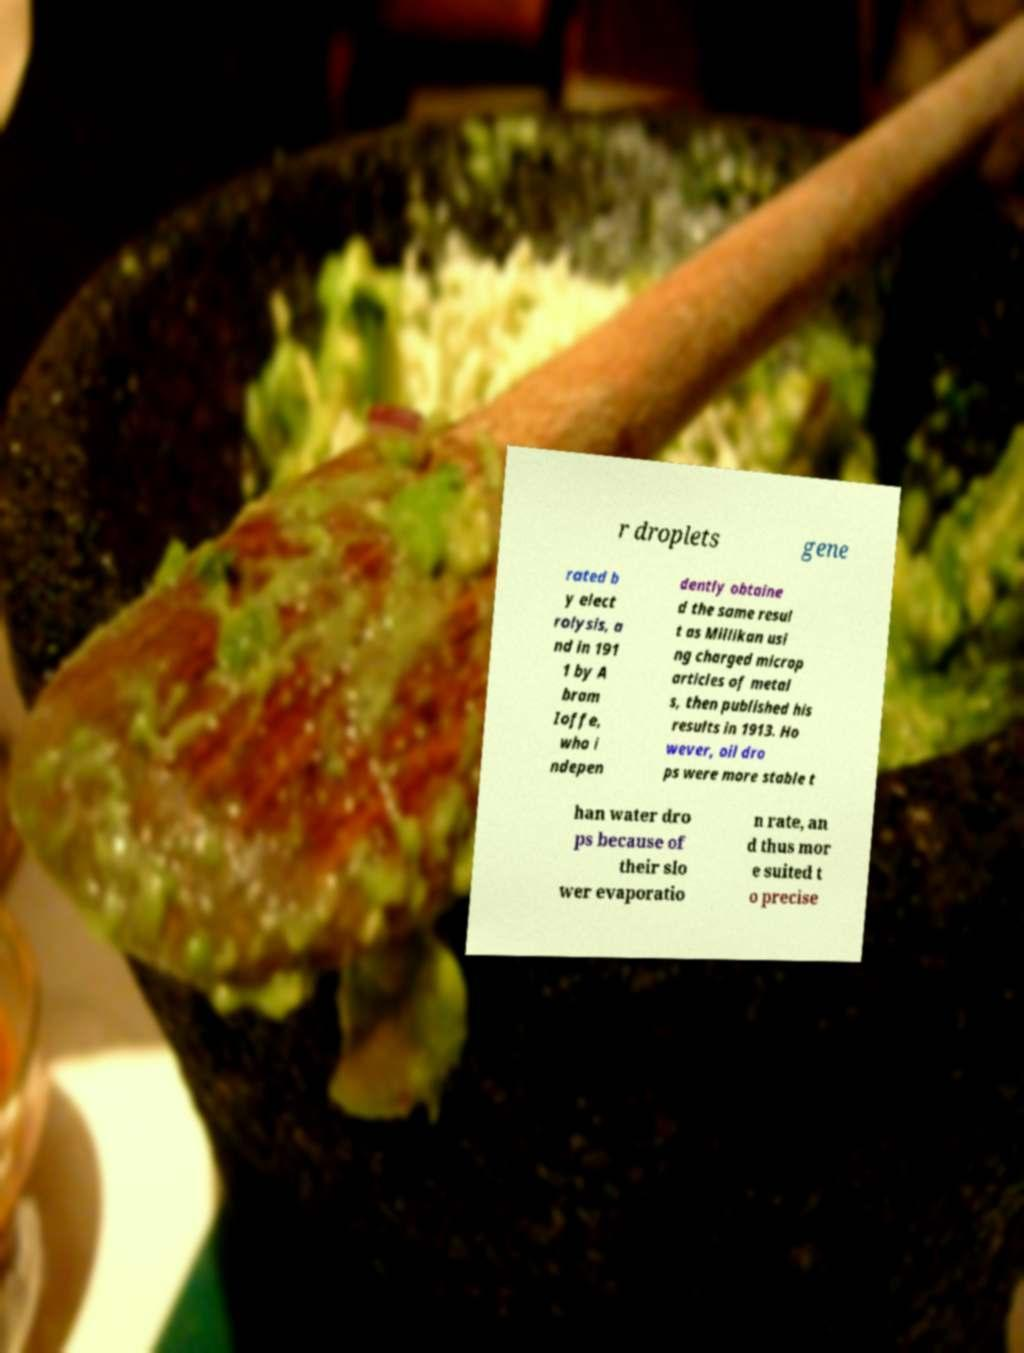Can you read and provide the text displayed in the image?This photo seems to have some interesting text. Can you extract and type it out for me? r droplets gene rated b y elect rolysis, a nd in 191 1 by A bram Ioffe, who i ndepen dently obtaine d the same resul t as Millikan usi ng charged microp articles of metal s, then published his results in 1913. Ho wever, oil dro ps were more stable t han water dro ps because of their slo wer evaporatio n rate, an d thus mor e suited t o precise 